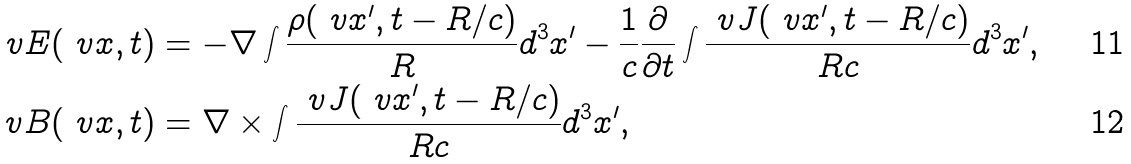<formula> <loc_0><loc_0><loc_500><loc_500>\ v E ( \ v x , t ) & = - \nabla \int \frac { \rho ( \ v x ^ { \prime } , t - R / c ) } { R } d ^ { 3 } x ^ { \prime } - \frac { 1 } { c } \frac { \partial } { \partial t } \int \frac { \ v J ( \ v x ^ { \prime } , t - R / c ) } { R c } d ^ { 3 } x ^ { \prime } , \\ \ v B ( \ v x , t ) & = \nabla \times \int \frac { \ v J ( \ v x ^ { \prime } , t - R / c ) } { R c } d ^ { 3 } x ^ { \prime } ,</formula> 